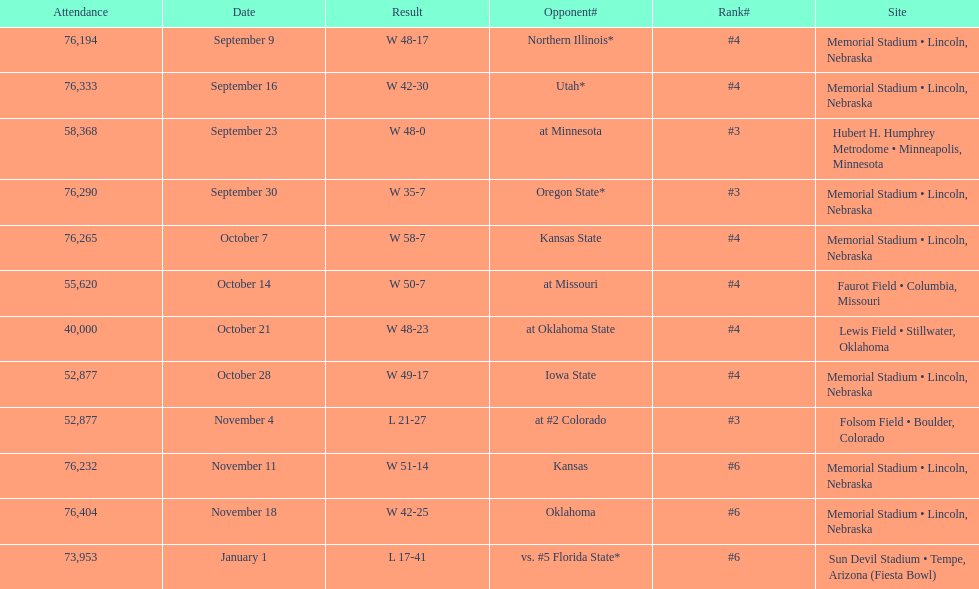Which site comes after lewis field on the list? Memorial Stadium • Lincoln, Nebraska. 